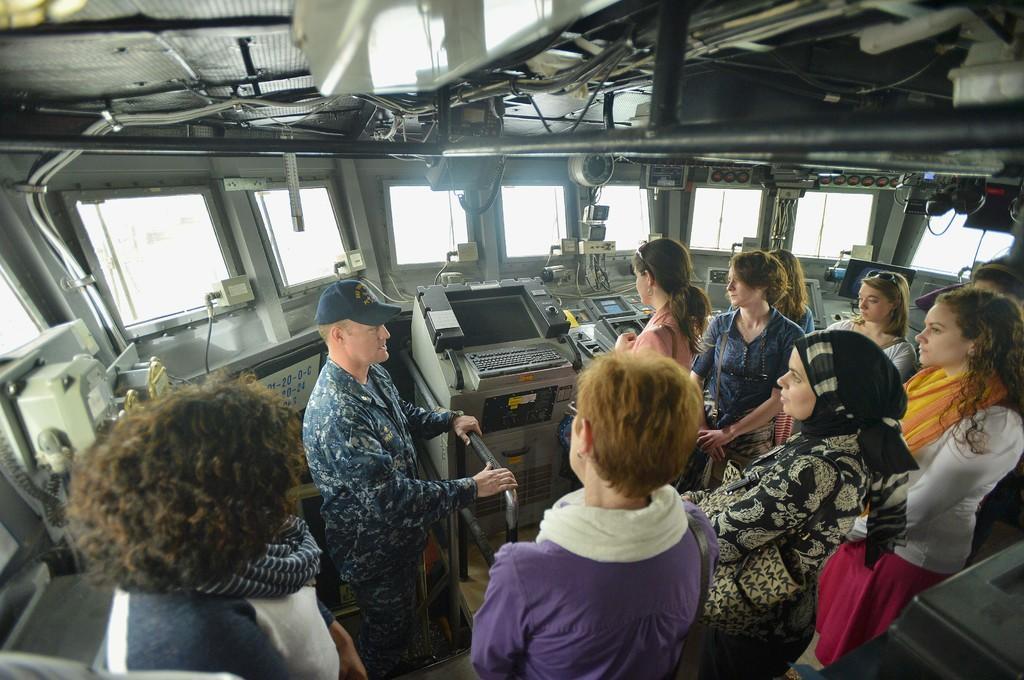Can you describe this image briefly? In this image we can see a group of people standing in a cabin along with an officer, there we can also see some operating machines, there we can also see some windows, wires and rods. 